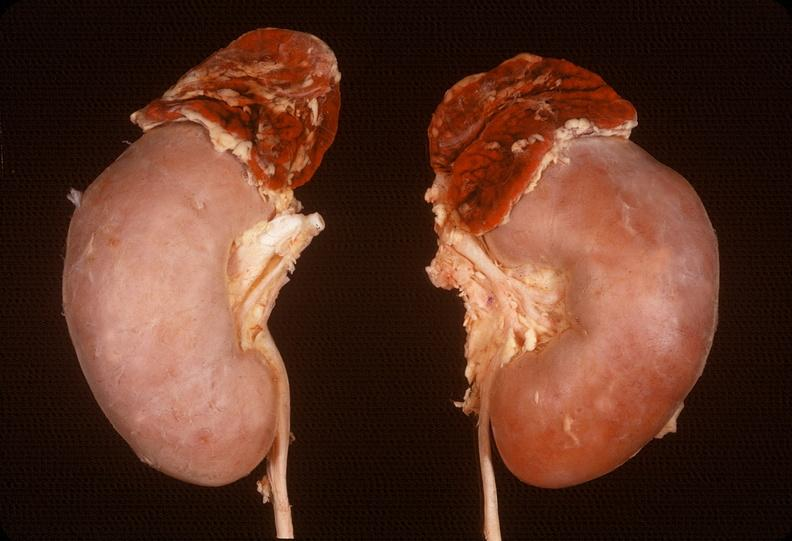what does this image show?
Answer the question using a single word or phrase. Adrenal 